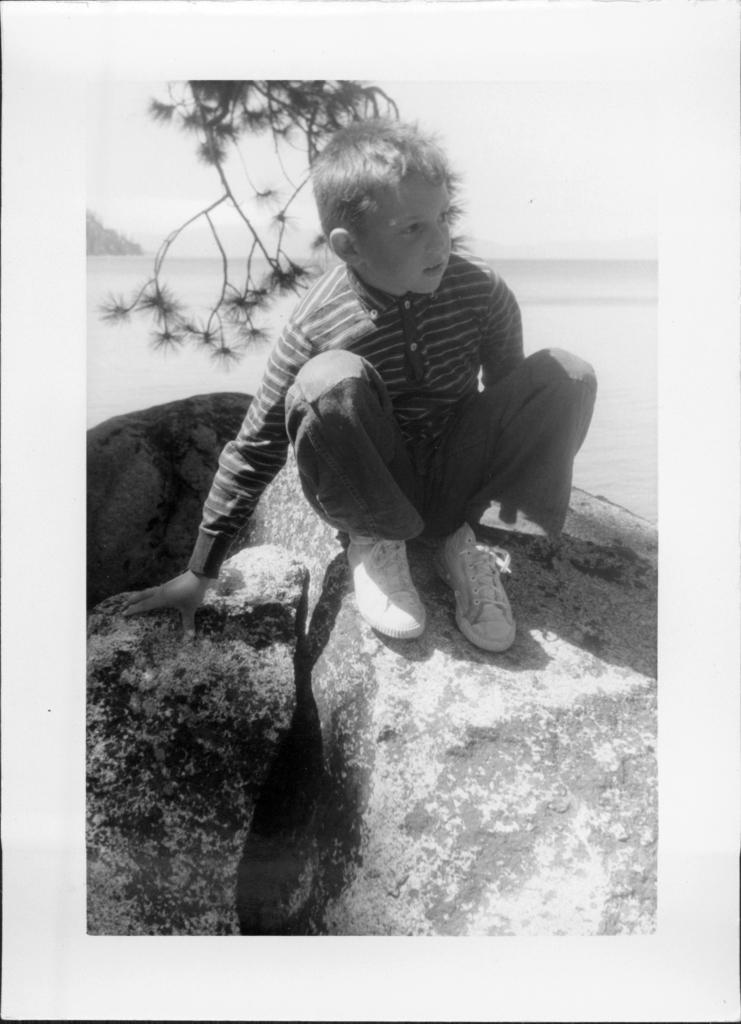What is the color scheme of the image? The image is in black and white. What is the boy doing in the image? The boy is sitting on a rock in the image. What can be seen behind the boy? There is a tree and water visible behind the boy. What is present in the background of the image? There are trees in the background of the image. What type of committee is responsible for the boy's debt in the image? There is no mention of debt or a committee in the image; it simply shows a boy sitting on a rock with a tree and water visible behind him. 